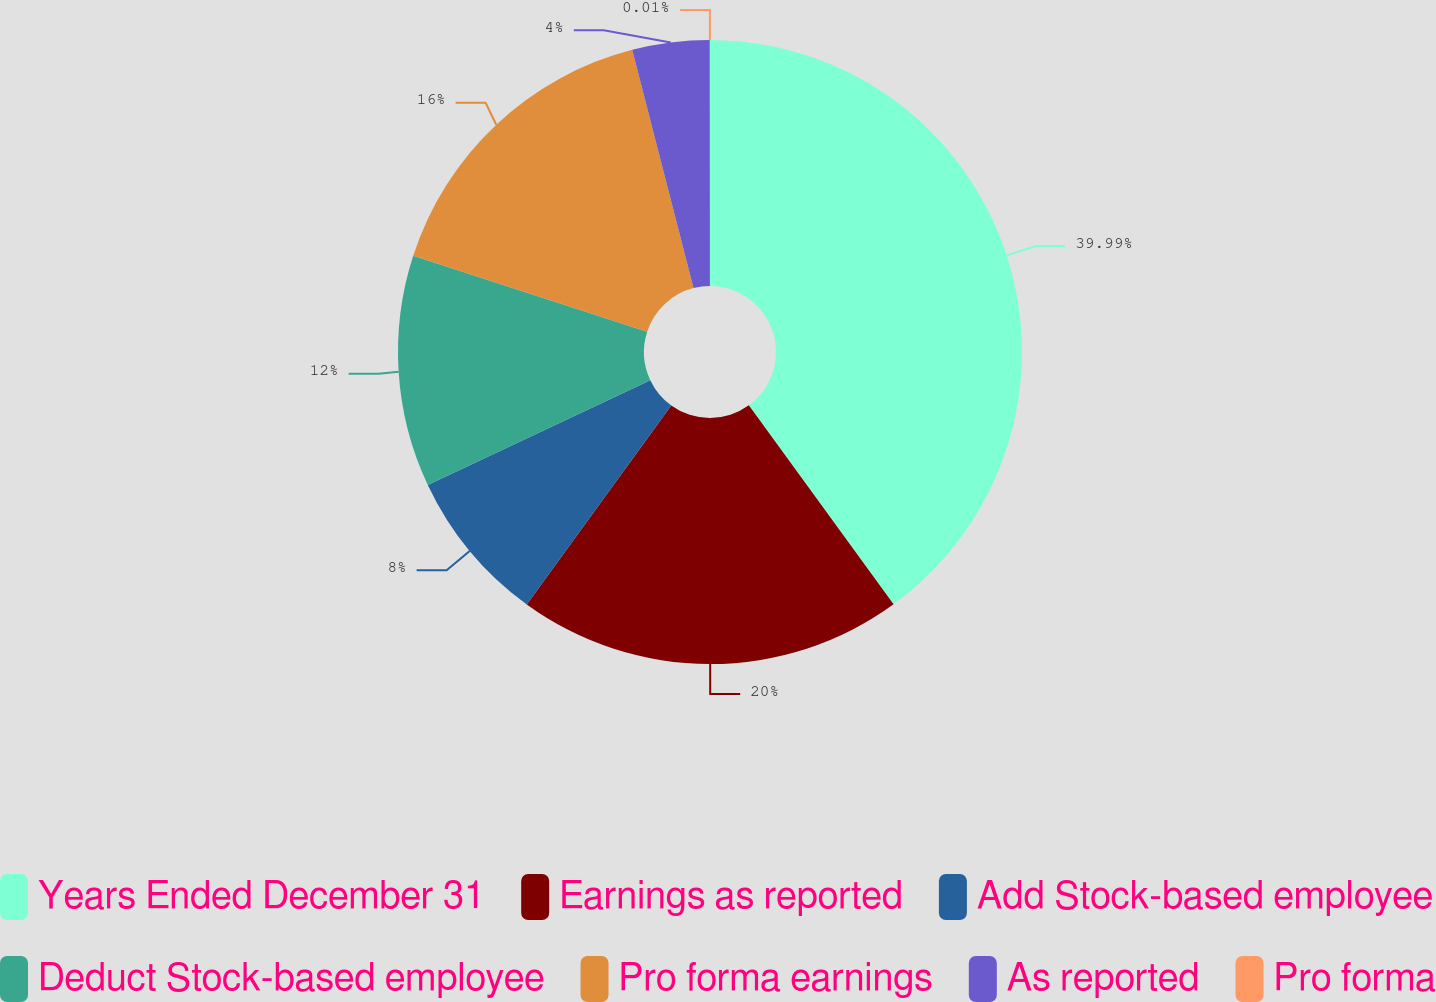Convert chart to OTSL. <chart><loc_0><loc_0><loc_500><loc_500><pie_chart><fcel>Years Ended December 31<fcel>Earnings as reported<fcel>Add Stock-based employee<fcel>Deduct Stock-based employee<fcel>Pro forma earnings<fcel>As reported<fcel>Pro forma<nl><fcel>39.99%<fcel>20.0%<fcel>8.0%<fcel>12.0%<fcel>16.0%<fcel>4.0%<fcel>0.01%<nl></chart> 